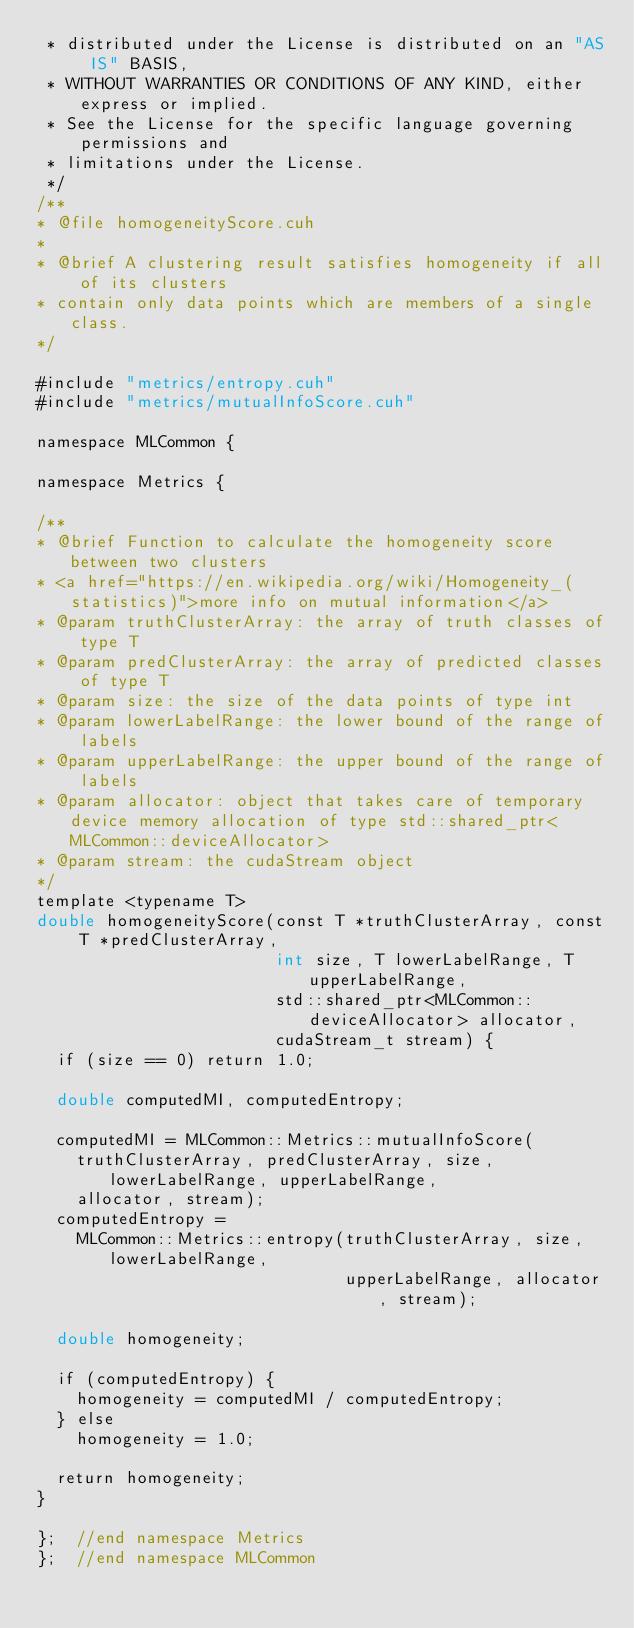Convert code to text. <code><loc_0><loc_0><loc_500><loc_500><_Cuda_> * distributed under the License is distributed on an "AS IS" BASIS,
 * WITHOUT WARRANTIES OR CONDITIONS OF ANY KIND, either express or implied.
 * See the License for the specific language governing permissions and
 * limitations under the License.
 */
/**
* @file homogeneityScore.cuh
*
* @brief A clustering result satisfies homogeneity if all of its clusters
* contain only data points which are members of a single class.
*/

#include "metrics/entropy.cuh"
#include "metrics/mutualInfoScore.cuh"

namespace MLCommon {

namespace Metrics {

/**
* @brief Function to calculate the homogeneity score between two clusters
* <a href="https://en.wikipedia.org/wiki/Homogeneity_(statistics)">more info on mutual information</a> 
* @param truthClusterArray: the array of truth classes of type T
* @param predClusterArray: the array of predicted classes of type T
* @param size: the size of the data points of type int
* @param lowerLabelRange: the lower bound of the range of labels
* @param upperLabelRange: the upper bound of the range of labels
* @param allocator: object that takes care of temporary device memory allocation of type std::shared_ptr<MLCommon::deviceAllocator>
* @param stream: the cudaStream object
*/
template <typename T>
double homogeneityScore(const T *truthClusterArray, const T *predClusterArray,
                        int size, T lowerLabelRange, T upperLabelRange,
                        std::shared_ptr<MLCommon::deviceAllocator> allocator,
                        cudaStream_t stream) {
  if (size == 0) return 1.0;

  double computedMI, computedEntropy;

  computedMI = MLCommon::Metrics::mutualInfoScore(
    truthClusterArray, predClusterArray, size, lowerLabelRange, upperLabelRange,
    allocator, stream);
  computedEntropy =
    MLCommon::Metrics::entropy(truthClusterArray, size, lowerLabelRange,
                               upperLabelRange, allocator, stream);

  double homogeneity;

  if (computedEntropy) {
    homogeneity = computedMI / computedEntropy;
  } else
    homogeneity = 1.0;

  return homogeneity;
}

};  //end namespace Metrics
};  //end namespace MLCommon
</code> 